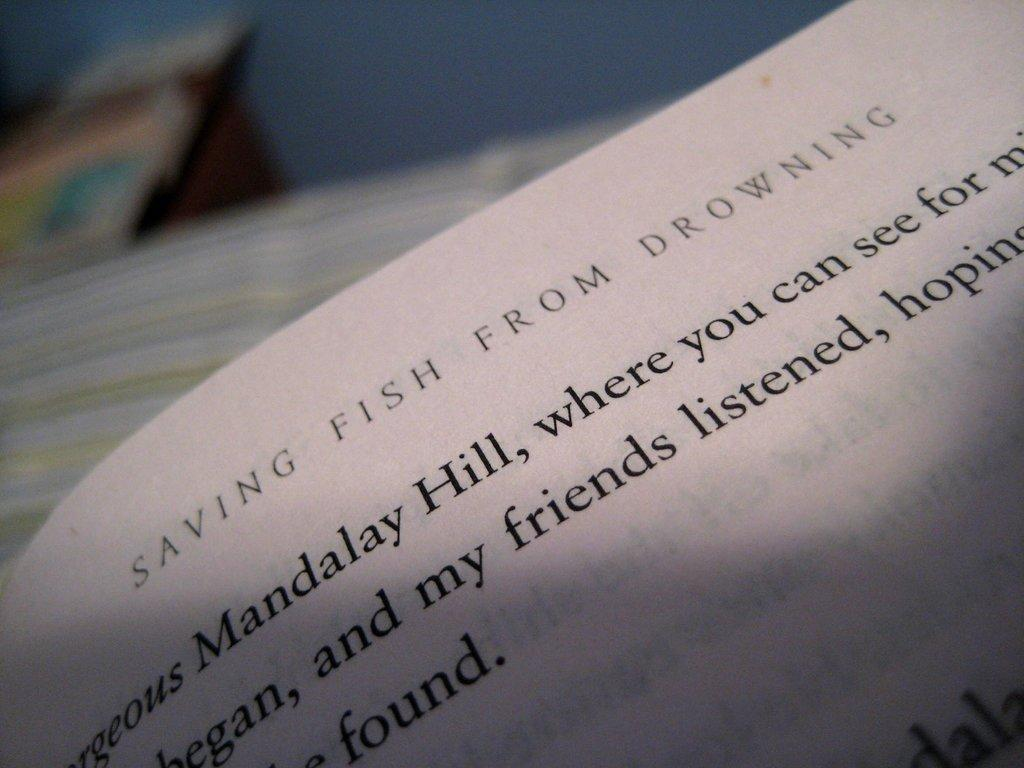Provide a one-sentence caption for the provided image. the top of a page from the book saving fish from drowning. 